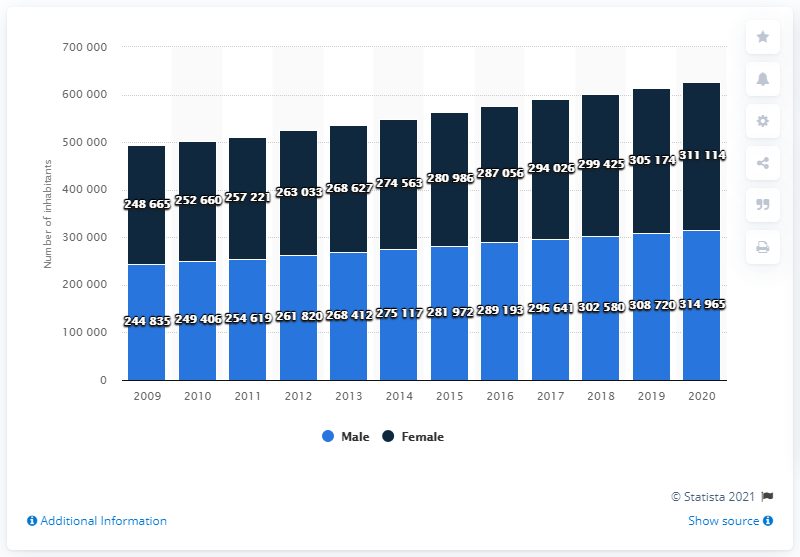Mention a couple of crucial points in this snapshot. In the year 2019, the male population of Luxembourg was 35,460 while the female population was 35,460, indicating no significant difference between the male and female populations of Luxembourg. In 2020, approximately 314,965 individuals in Luxembourg were male. In 2012, the male population of Luxembourg was 261,820. As of 2020, the female population of Luxembourg was estimated to be 311,114. 